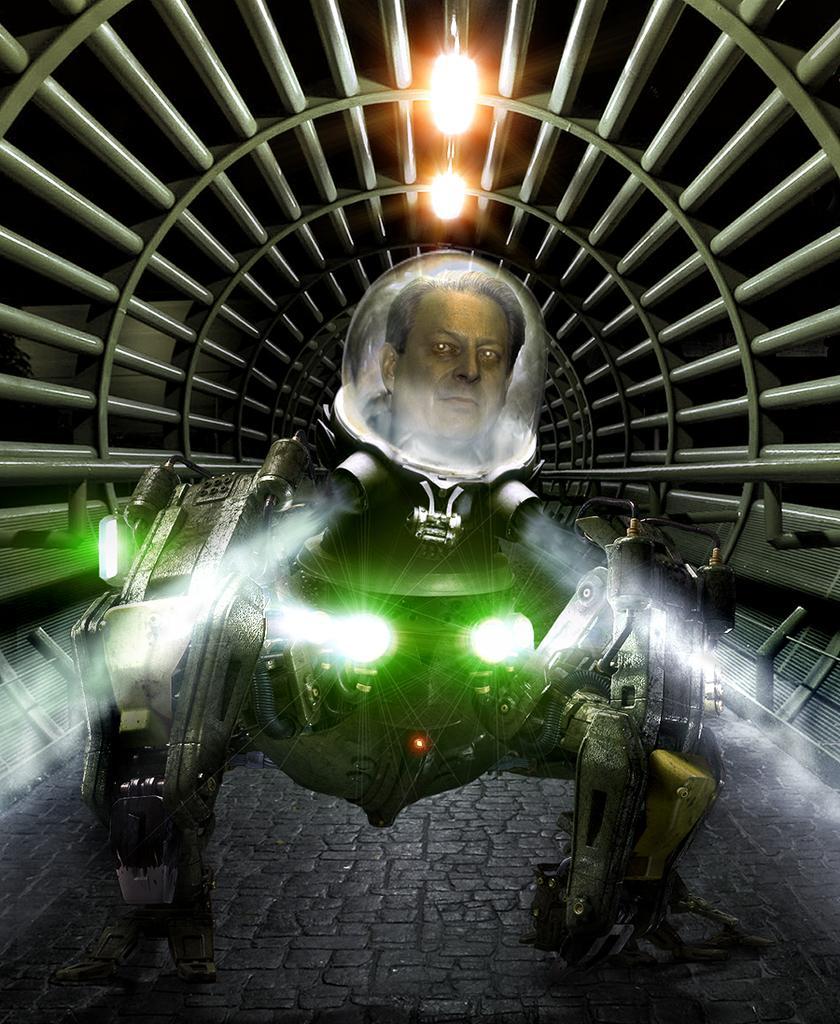Describe this image in one or two sentences. In this image I can see machine which is on the path and there is a man face in it. In the background I can see the lights 